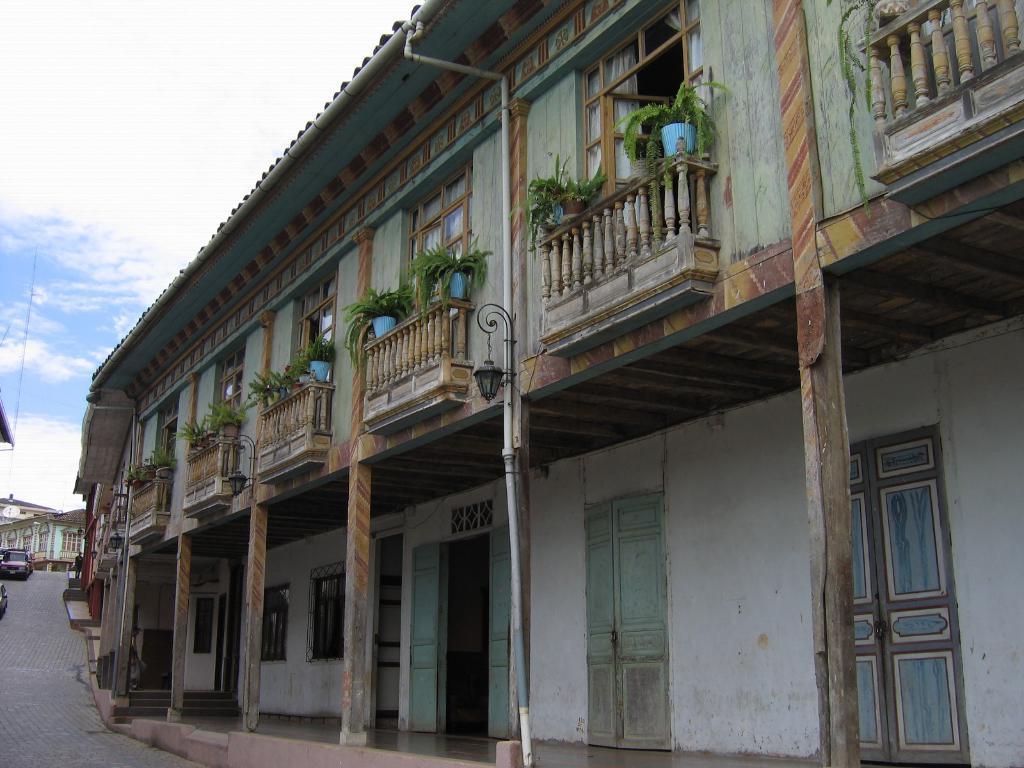Describe this image in one or two sentences. In this image I can see a building in gray and brown color. I can also see few plants in green color, background I can see few vehicles on the road and sky is in blue and white color. 